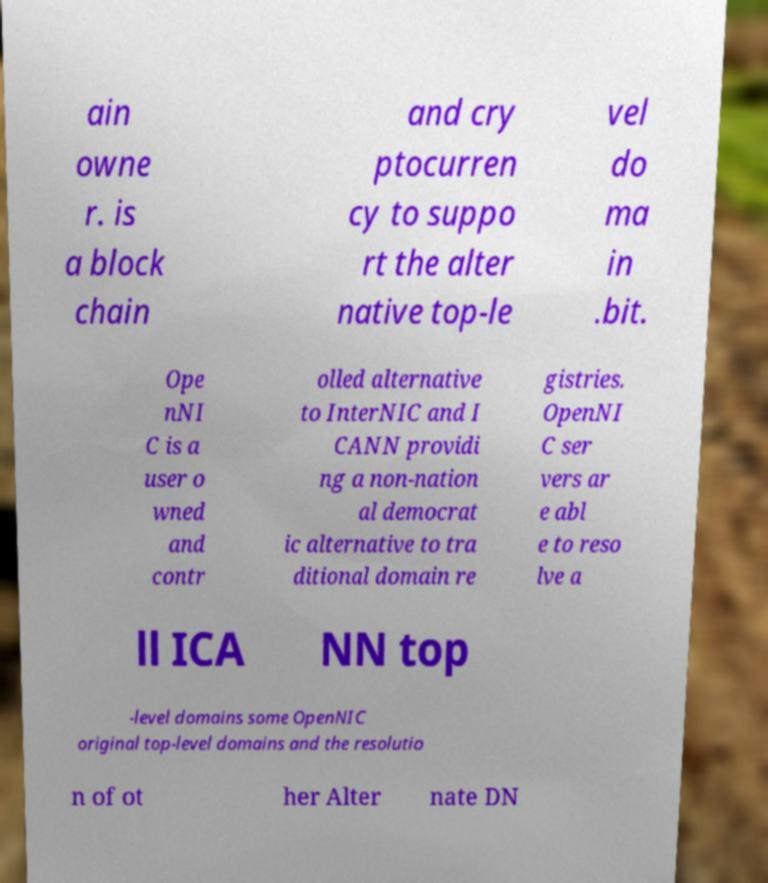There's text embedded in this image that I need extracted. Can you transcribe it verbatim? ain owne r. is a block chain and cry ptocurren cy to suppo rt the alter native top-le vel do ma in .bit. Ope nNI C is a user o wned and contr olled alternative to InterNIC and I CANN providi ng a non-nation al democrat ic alternative to tra ditional domain re gistries. OpenNI C ser vers ar e abl e to reso lve a ll ICA NN top -level domains some OpenNIC original top-level domains and the resolutio n of ot her Alter nate DN 